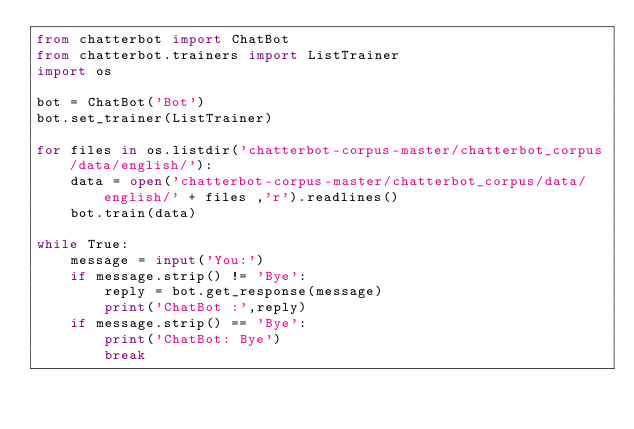Convert code to text. <code><loc_0><loc_0><loc_500><loc_500><_Python_>from chatterbot import ChatBot
from chatterbot.trainers import ListTrainer
import os

bot = ChatBot('Bot')
bot.set_trainer(ListTrainer)

for files in os.listdir('chatterbot-corpus-master/chatterbot_corpus/data/english/'):
	data = open('chatterbot-corpus-master/chatterbot_corpus/data/english/' + files ,'r').readlines()
	bot.train(data)

while True:
	message = input('You:')
	if message.strip() != 'Bye':
		reply = bot.get_response(message)
		print('ChatBot :',reply)
	if message.strip() == 'Bye':
		print('ChatBot: Bye')
		break</code> 